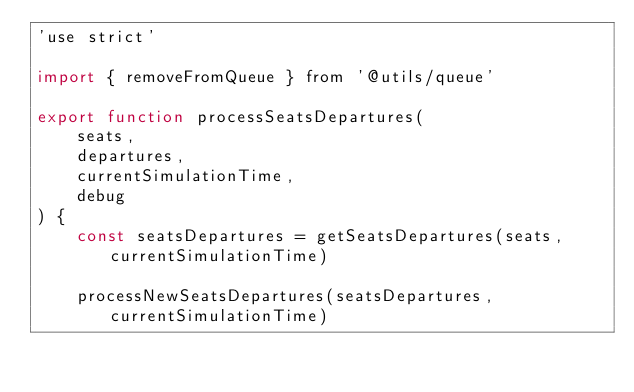<code> <loc_0><loc_0><loc_500><loc_500><_JavaScript_>'use strict'

import { removeFromQueue } from '@utils/queue'

export function processSeatsDepartures(
    seats,
    departures,
    currentSimulationTime,
    debug
) {
    const seatsDepartures = getSeatsDepartures(seats, currentSimulationTime)

    processNewSeatsDepartures(seatsDepartures, currentSimulationTime)</code> 